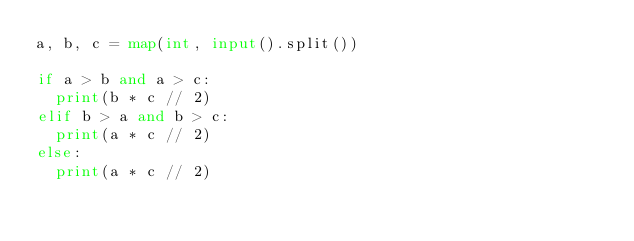Convert code to text. <code><loc_0><loc_0><loc_500><loc_500><_Python_>a, b, c = map(int, input().split())

if a > b and a > c:
  print(b * c // 2)
elif b > a and b > c:
  print(a * c // 2)
else:
  print(a * c // 2)
</code> 